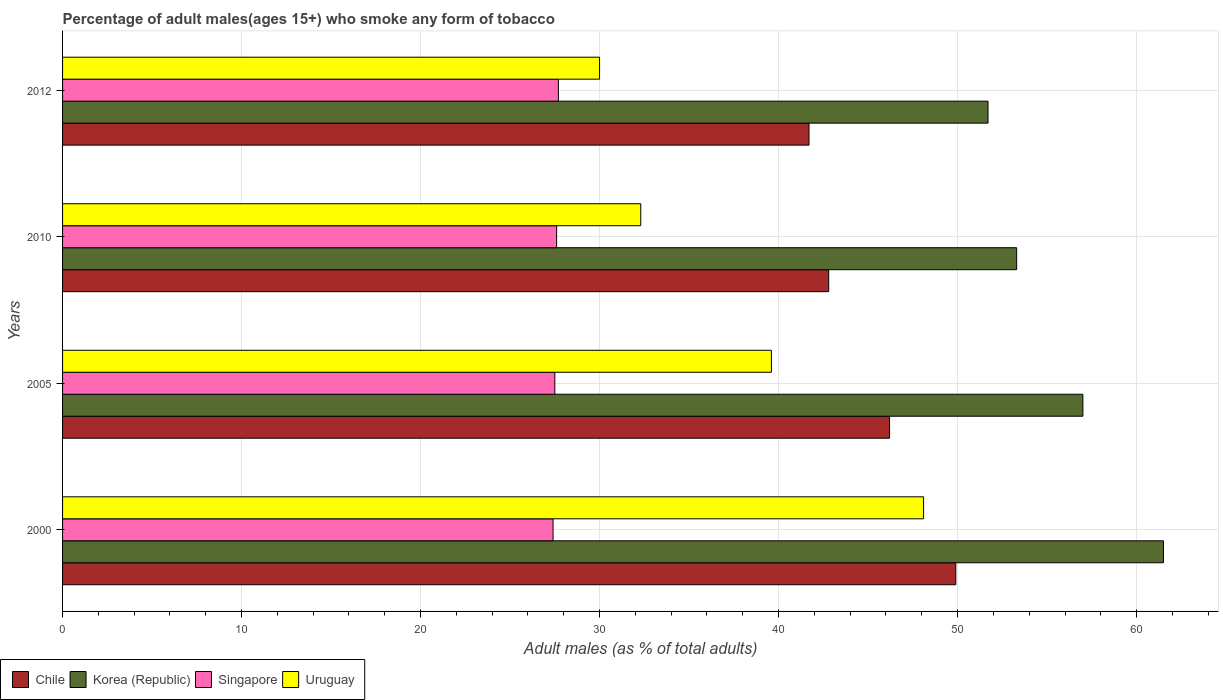How many groups of bars are there?
Provide a short and direct response. 4. How many bars are there on the 3rd tick from the top?
Provide a short and direct response. 4. In how many cases, is the number of bars for a given year not equal to the number of legend labels?
Your answer should be very brief. 0. What is the percentage of adult males who smoke in Chile in 2010?
Make the answer very short. 42.8. Across all years, what is the maximum percentage of adult males who smoke in Korea (Republic)?
Your answer should be very brief. 61.5. Across all years, what is the minimum percentage of adult males who smoke in Korea (Republic)?
Offer a very short reply. 51.7. What is the total percentage of adult males who smoke in Korea (Republic) in the graph?
Make the answer very short. 223.5. What is the difference between the percentage of adult males who smoke in Chile in 2010 and that in 2012?
Provide a succinct answer. 1.1. What is the difference between the percentage of adult males who smoke in Singapore in 2010 and the percentage of adult males who smoke in Korea (Republic) in 2012?
Make the answer very short. -24.1. What is the average percentage of adult males who smoke in Singapore per year?
Offer a terse response. 27.55. In the year 2012, what is the difference between the percentage of adult males who smoke in Singapore and percentage of adult males who smoke in Chile?
Your answer should be compact. -14. What is the ratio of the percentage of adult males who smoke in Uruguay in 2000 to that in 2005?
Your answer should be very brief. 1.21. What is the difference between the highest and the second highest percentage of adult males who smoke in Singapore?
Your answer should be very brief. 0.1. What is the difference between the highest and the lowest percentage of adult males who smoke in Uruguay?
Your answer should be very brief. 18.1. In how many years, is the percentage of adult males who smoke in Uruguay greater than the average percentage of adult males who smoke in Uruguay taken over all years?
Provide a succinct answer. 2. Is the sum of the percentage of adult males who smoke in Korea (Republic) in 2000 and 2010 greater than the maximum percentage of adult males who smoke in Singapore across all years?
Provide a short and direct response. Yes. Is it the case that in every year, the sum of the percentage of adult males who smoke in Korea (Republic) and percentage of adult males who smoke in Uruguay is greater than the sum of percentage of adult males who smoke in Singapore and percentage of adult males who smoke in Chile?
Make the answer very short. No. What does the 3rd bar from the top in 2000 represents?
Make the answer very short. Korea (Republic). What does the 3rd bar from the bottom in 2005 represents?
Your answer should be compact. Singapore. How many bars are there?
Keep it short and to the point. 16. How many years are there in the graph?
Offer a very short reply. 4. What is the difference between two consecutive major ticks on the X-axis?
Your response must be concise. 10. Are the values on the major ticks of X-axis written in scientific E-notation?
Make the answer very short. No. Does the graph contain any zero values?
Your response must be concise. No. Where does the legend appear in the graph?
Your answer should be very brief. Bottom left. How many legend labels are there?
Your response must be concise. 4. How are the legend labels stacked?
Keep it short and to the point. Horizontal. What is the title of the graph?
Offer a terse response. Percentage of adult males(ages 15+) who smoke any form of tobacco. Does "Low income" appear as one of the legend labels in the graph?
Provide a short and direct response. No. What is the label or title of the X-axis?
Keep it short and to the point. Adult males (as % of total adults). What is the Adult males (as % of total adults) in Chile in 2000?
Give a very brief answer. 49.9. What is the Adult males (as % of total adults) of Korea (Republic) in 2000?
Provide a succinct answer. 61.5. What is the Adult males (as % of total adults) in Singapore in 2000?
Provide a short and direct response. 27.4. What is the Adult males (as % of total adults) of Uruguay in 2000?
Your response must be concise. 48.1. What is the Adult males (as % of total adults) in Chile in 2005?
Give a very brief answer. 46.2. What is the Adult males (as % of total adults) of Singapore in 2005?
Your answer should be very brief. 27.5. What is the Adult males (as % of total adults) of Uruguay in 2005?
Offer a terse response. 39.6. What is the Adult males (as % of total adults) in Chile in 2010?
Offer a terse response. 42.8. What is the Adult males (as % of total adults) of Korea (Republic) in 2010?
Offer a terse response. 53.3. What is the Adult males (as % of total adults) of Singapore in 2010?
Ensure brevity in your answer.  27.6. What is the Adult males (as % of total adults) of Uruguay in 2010?
Provide a succinct answer. 32.3. What is the Adult males (as % of total adults) of Chile in 2012?
Give a very brief answer. 41.7. What is the Adult males (as % of total adults) in Korea (Republic) in 2012?
Ensure brevity in your answer.  51.7. What is the Adult males (as % of total adults) of Singapore in 2012?
Keep it short and to the point. 27.7. What is the Adult males (as % of total adults) of Uruguay in 2012?
Your response must be concise. 30. Across all years, what is the maximum Adult males (as % of total adults) in Chile?
Your response must be concise. 49.9. Across all years, what is the maximum Adult males (as % of total adults) of Korea (Republic)?
Make the answer very short. 61.5. Across all years, what is the maximum Adult males (as % of total adults) of Singapore?
Make the answer very short. 27.7. Across all years, what is the maximum Adult males (as % of total adults) in Uruguay?
Your answer should be very brief. 48.1. Across all years, what is the minimum Adult males (as % of total adults) in Chile?
Keep it short and to the point. 41.7. Across all years, what is the minimum Adult males (as % of total adults) in Korea (Republic)?
Offer a very short reply. 51.7. Across all years, what is the minimum Adult males (as % of total adults) of Singapore?
Provide a succinct answer. 27.4. What is the total Adult males (as % of total adults) in Chile in the graph?
Give a very brief answer. 180.6. What is the total Adult males (as % of total adults) of Korea (Republic) in the graph?
Make the answer very short. 223.5. What is the total Adult males (as % of total adults) in Singapore in the graph?
Provide a short and direct response. 110.2. What is the total Adult males (as % of total adults) in Uruguay in the graph?
Keep it short and to the point. 150. What is the difference between the Adult males (as % of total adults) of Korea (Republic) in 2000 and that in 2005?
Your response must be concise. 4.5. What is the difference between the Adult males (as % of total adults) of Uruguay in 2000 and that in 2005?
Give a very brief answer. 8.5. What is the difference between the Adult males (as % of total adults) of Uruguay in 2000 and that in 2010?
Your answer should be very brief. 15.8. What is the difference between the Adult males (as % of total adults) in Chile in 2000 and that in 2012?
Give a very brief answer. 8.2. What is the difference between the Adult males (as % of total adults) in Korea (Republic) in 2000 and that in 2012?
Make the answer very short. 9.8. What is the difference between the Adult males (as % of total adults) of Korea (Republic) in 2005 and that in 2010?
Provide a short and direct response. 3.7. What is the difference between the Adult males (as % of total adults) in Singapore in 2005 and that in 2010?
Your answer should be compact. -0.1. What is the difference between the Adult males (as % of total adults) in Chile in 2005 and that in 2012?
Offer a very short reply. 4.5. What is the difference between the Adult males (as % of total adults) of Singapore in 2005 and that in 2012?
Your response must be concise. -0.2. What is the difference between the Adult males (as % of total adults) in Singapore in 2010 and that in 2012?
Keep it short and to the point. -0.1. What is the difference between the Adult males (as % of total adults) of Chile in 2000 and the Adult males (as % of total adults) of Singapore in 2005?
Give a very brief answer. 22.4. What is the difference between the Adult males (as % of total adults) of Chile in 2000 and the Adult males (as % of total adults) of Uruguay in 2005?
Your answer should be very brief. 10.3. What is the difference between the Adult males (as % of total adults) of Korea (Republic) in 2000 and the Adult males (as % of total adults) of Singapore in 2005?
Your answer should be very brief. 34. What is the difference between the Adult males (as % of total adults) of Korea (Republic) in 2000 and the Adult males (as % of total adults) of Uruguay in 2005?
Ensure brevity in your answer.  21.9. What is the difference between the Adult males (as % of total adults) in Chile in 2000 and the Adult males (as % of total adults) in Korea (Republic) in 2010?
Your answer should be very brief. -3.4. What is the difference between the Adult males (as % of total adults) in Chile in 2000 and the Adult males (as % of total adults) in Singapore in 2010?
Offer a very short reply. 22.3. What is the difference between the Adult males (as % of total adults) of Chile in 2000 and the Adult males (as % of total adults) of Uruguay in 2010?
Give a very brief answer. 17.6. What is the difference between the Adult males (as % of total adults) of Korea (Republic) in 2000 and the Adult males (as % of total adults) of Singapore in 2010?
Your answer should be very brief. 33.9. What is the difference between the Adult males (as % of total adults) in Korea (Republic) in 2000 and the Adult males (as % of total adults) in Uruguay in 2010?
Ensure brevity in your answer.  29.2. What is the difference between the Adult males (as % of total adults) in Singapore in 2000 and the Adult males (as % of total adults) in Uruguay in 2010?
Provide a short and direct response. -4.9. What is the difference between the Adult males (as % of total adults) in Chile in 2000 and the Adult males (as % of total adults) in Korea (Republic) in 2012?
Provide a succinct answer. -1.8. What is the difference between the Adult males (as % of total adults) in Chile in 2000 and the Adult males (as % of total adults) in Singapore in 2012?
Ensure brevity in your answer.  22.2. What is the difference between the Adult males (as % of total adults) in Korea (Republic) in 2000 and the Adult males (as % of total adults) in Singapore in 2012?
Offer a very short reply. 33.8. What is the difference between the Adult males (as % of total adults) in Korea (Republic) in 2000 and the Adult males (as % of total adults) in Uruguay in 2012?
Offer a very short reply. 31.5. What is the difference between the Adult males (as % of total adults) in Chile in 2005 and the Adult males (as % of total adults) in Korea (Republic) in 2010?
Keep it short and to the point. -7.1. What is the difference between the Adult males (as % of total adults) in Chile in 2005 and the Adult males (as % of total adults) in Uruguay in 2010?
Provide a short and direct response. 13.9. What is the difference between the Adult males (as % of total adults) in Korea (Republic) in 2005 and the Adult males (as % of total adults) in Singapore in 2010?
Your answer should be compact. 29.4. What is the difference between the Adult males (as % of total adults) of Korea (Republic) in 2005 and the Adult males (as % of total adults) of Uruguay in 2010?
Your answer should be very brief. 24.7. What is the difference between the Adult males (as % of total adults) in Singapore in 2005 and the Adult males (as % of total adults) in Uruguay in 2010?
Your answer should be compact. -4.8. What is the difference between the Adult males (as % of total adults) of Chile in 2005 and the Adult males (as % of total adults) of Korea (Republic) in 2012?
Offer a terse response. -5.5. What is the difference between the Adult males (as % of total adults) in Chile in 2005 and the Adult males (as % of total adults) in Singapore in 2012?
Give a very brief answer. 18.5. What is the difference between the Adult males (as % of total adults) of Chile in 2005 and the Adult males (as % of total adults) of Uruguay in 2012?
Your answer should be compact. 16.2. What is the difference between the Adult males (as % of total adults) in Korea (Republic) in 2005 and the Adult males (as % of total adults) in Singapore in 2012?
Make the answer very short. 29.3. What is the difference between the Adult males (as % of total adults) in Singapore in 2005 and the Adult males (as % of total adults) in Uruguay in 2012?
Offer a terse response. -2.5. What is the difference between the Adult males (as % of total adults) in Chile in 2010 and the Adult males (as % of total adults) in Uruguay in 2012?
Keep it short and to the point. 12.8. What is the difference between the Adult males (as % of total adults) in Korea (Republic) in 2010 and the Adult males (as % of total adults) in Singapore in 2012?
Provide a succinct answer. 25.6. What is the difference between the Adult males (as % of total adults) in Korea (Republic) in 2010 and the Adult males (as % of total adults) in Uruguay in 2012?
Give a very brief answer. 23.3. What is the difference between the Adult males (as % of total adults) in Singapore in 2010 and the Adult males (as % of total adults) in Uruguay in 2012?
Make the answer very short. -2.4. What is the average Adult males (as % of total adults) of Chile per year?
Keep it short and to the point. 45.15. What is the average Adult males (as % of total adults) of Korea (Republic) per year?
Your answer should be compact. 55.88. What is the average Adult males (as % of total adults) of Singapore per year?
Ensure brevity in your answer.  27.55. What is the average Adult males (as % of total adults) of Uruguay per year?
Offer a terse response. 37.5. In the year 2000, what is the difference between the Adult males (as % of total adults) of Chile and Adult males (as % of total adults) of Korea (Republic)?
Your answer should be very brief. -11.6. In the year 2000, what is the difference between the Adult males (as % of total adults) of Chile and Adult males (as % of total adults) of Singapore?
Your response must be concise. 22.5. In the year 2000, what is the difference between the Adult males (as % of total adults) in Chile and Adult males (as % of total adults) in Uruguay?
Give a very brief answer. 1.8. In the year 2000, what is the difference between the Adult males (as % of total adults) in Korea (Republic) and Adult males (as % of total adults) in Singapore?
Give a very brief answer. 34.1. In the year 2000, what is the difference between the Adult males (as % of total adults) in Korea (Republic) and Adult males (as % of total adults) in Uruguay?
Give a very brief answer. 13.4. In the year 2000, what is the difference between the Adult males (as % of total adults) in Singapore and Adult males (as % of total adults) in Uruguay?
Provide a short and direct response. -20.7. In the year 2005, what is the difference between the Adult males (as % of total adults) of Chile and Adult males (as % of total adults) of Uruguay?
Give a very brief answer. 6.6. In the year 2005, what is the difference between the Adult males (as % of total adults) of Korea (Republic) and Adult males (as % of total adults) of Singapore?
Provide a succinct answer. 29.5. In the year 2010, what is the difference between the Adult males (as % of total adults) of Chile and Adult males (as % of total adults) of Uruguay?
Keep it short and to the point. 10.5. In the year 2010, what is the difference between the Adult males (as % of total adults) in Korea (Republic) and Adult males (as % of total adults) in Singapore?
Ensure brevity in your answer.  25.7. In the year 2010, what is the difference between the Adult males (as % of total adults) in Korea (Republic) and Adult males (as % of total adults) in Uruguay?
Provide a short and direct response. 21. In the year 2010, what is the difference between the Adult males (as % of total adults) of Singapore and Adult males (as % of total adults) of Uruguay?
Offer a very short reply. -4.7. In the year 2012, what is the difference between the Adult males (as % of total adults) in Chile and Adult males (as % of total adults) in Korea (Republic)?
Your answer should be compact. -10. In the year 2012, what is the difference between the Adult males (as % of total adults) in Chile and Adult males (as % of total adults) in Uruguay?
Your answer should be compact. 11.7. In the year 2012, what is the difference between the Adult males (as % of total adults) of Korea (Republic) and Adult males (as % of total adults) of Singapore?
Give a very brief answer. 24. In the year 2012, what is the difference between the Adult males (as % of total adults) in Korea (Republic) and Adult males (as % of total adults) in Uruguay?
Provide a short and direct response. 21.7. In the year 2012, what is the difference between the Adult males (as % of total adults) in Singapore and Adult males (as % of total adults) in Uruguay?
Provide a succinct answer. -2.3. What is the ratio of the Adult males (as % of total adults) of Chile in 2000 to that in 2005?
Offer a very short reply. 1.08. What is the ratio of the Adult males (as % of total adults) in Korea (Republic) in 2000 to that in 2005?
Keep it short and to the point. 1.08. What is the ratio of the Adult males (as % of total adults) in Uruguay in 2000 to that in 2005?
Provide a succinct answer. 1.21. What is the ratio of the Adult males (as % of total adults) in Chile in 2000 to that in 2010?
Provide a short and direct response. 1.17. What is the ratio of the Adult males (as % of total adults) of Korea (Republic) in 2000 to that in 2010?
Your answer should be compact. 1.15. What is the ratio of the Adult males (as % of total adults) in Uruguay in 2000 to that in 2010?
Provide a short and direct response. 1.49. What is the ratio of the Adult males (as % of total adults) of Chile in 2000 to that in 2012?
Offer a terse response. 1.2. What is the ratio of the Adult males (as % of total adults) in Korea (Republic) in 2000 to that in 2012?
Make the answer very short. 1.19. What is the ratio of the Adult males (as % of total adults) in Uruguay in 2000 to that in 2012?
Make the answer very short. 1.6. What is the ratio of the Adult males (as % of total adults) of Chile in 2005 to that in 2010?
Make the answer very short. 1.08. What is the ratio of the Adult males (as % of total adults) in Korea (Republic) in 2005 to that in 2010?
Give a very brief answer. 1.07. What is the ratio of the Adult males (as % of total adults) of Singapore in 2005 to that in 2010?
Make the answer very short. 1. What is the ratio of the Adult males (as % of total adults) in Uruguay in 2005 to that in 2010?
Make the answer very short. 1.23. What is the ratio of the Adult males (as % of total adults) of Chile in 2005 to that in 2012?
Give a very brief answer. 1.11. What is the ratio of the Adult males (as % of total adults) in Korea (Republic) in 2005 to that in 2012?
Offer a very short reply. 1.1. What is the ratio of the Adult males (as % of total adults) in Singapore in 2005 to that in 2012?
Your response must be concise. 0.99. What is the ratio of the Adult males (as % of total adults) in Uruguay in 2005 to that in 2012?
Offer a terse response. 1.32. What is the ratio of the Adult males (as % of total adults) of Chile in 2010 to that in 2012?
Give a very brief answer. 1.03. What is the ratio of the Adult males (as % of total adults) in Korea (Republic) in 2010 to that in 2012?
Your answer should be very brief. 1.03. What is the ratio of the Adult males (as % of total adults) of Singapore in 2010 to that in 2012?
Provide a succinct answer. 1. What is the ratio of the Adult males (as % of total adults) in Uruguay in 2010 to that in 2012?
Provide a short and direct response. 1.08. What is the difference between the highest and the second highest Adult males (as % of total adults) in Korea (Republic)?
Offer a terse response. 4.5. What is the difference between the highest and the lowest Adult males (as % of total adults) of Korea (Republic)?
Offer a terse response. 9.8. What is the difference between the highest and the lowest Adult males (as % of total adults) in Singapore?
Provide a succinct answer. 0.3. What is the difference between the highest and the lowest Adult males (as % of total adults) in Uruguay?
Give a very brief answer. 18.1. 